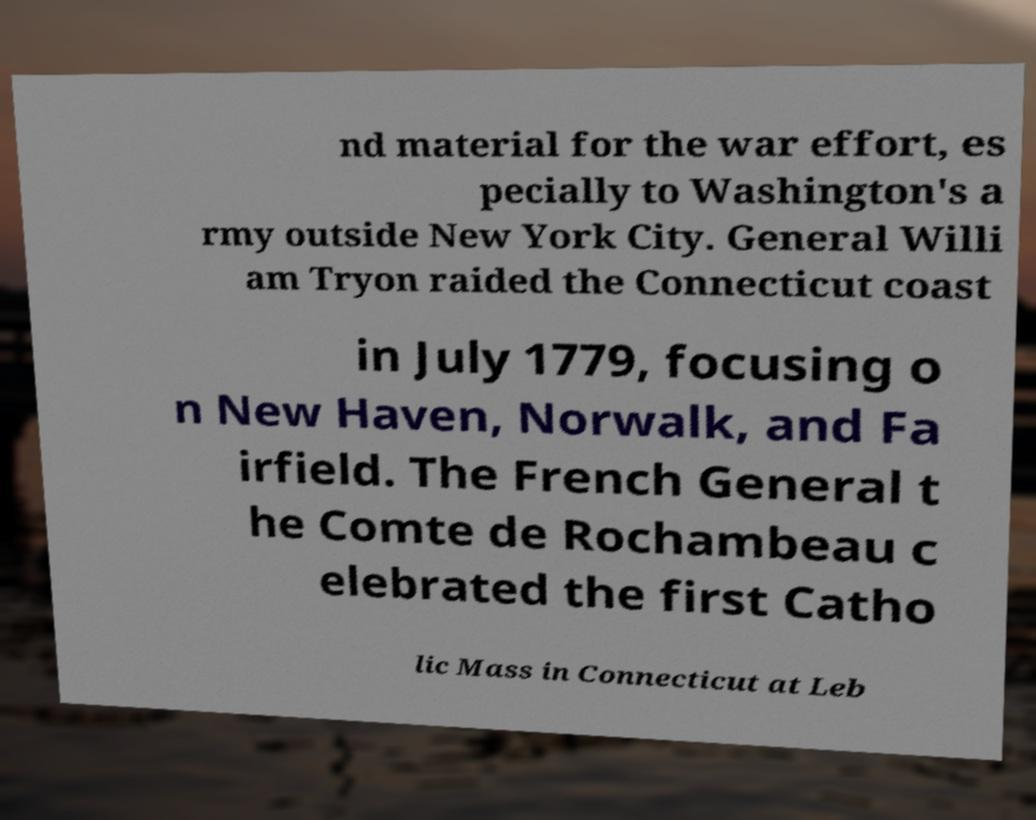Please identify and transcribe the text found in this image. nd material for the war effort, es pecially to Washington's a rmy outside New York City. General Willi am Tryon raided the Connecticut coast in July 1779, focusing o n New Haven, Norwalk, and Fa irfield. The French General t he Comte de Rochambeau c elebrated the first Catho lic Mass in Connecticut at Leb 